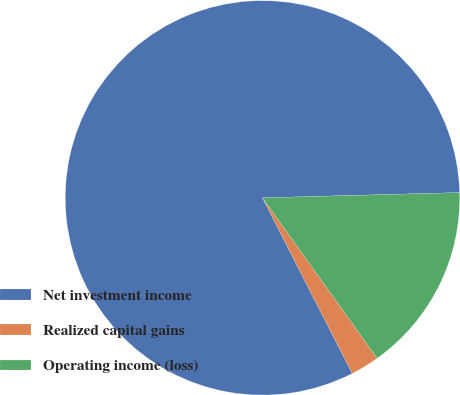Convert chart. <chart><loc_0><loc_0><loc_500><loc_500><pie_chart><fcel>Net investment income<fcel>Realized capital gains<fcel>Operating income (loss)<nl><fcel>82.09%<fcel>2.36%<fcel>15.55%<nl></chart> 